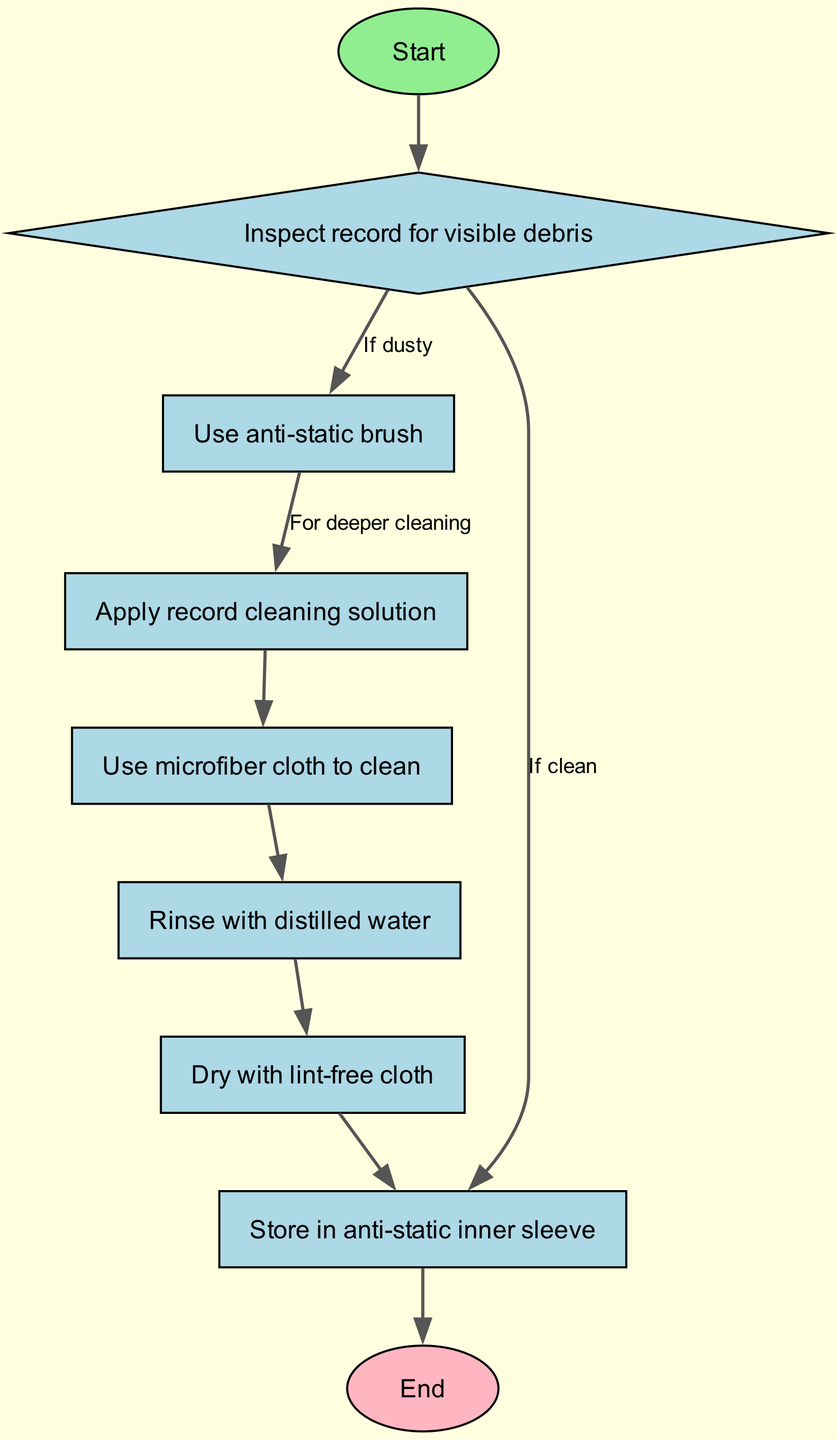What is the starting point of the process? The starting point is represented by the node labeled 'Start' at the top of the flow chart. It directs to the first main action of inspecting the record.
Answer: Start How many nodes are present in the diagram? The diagram contains a total of 7 nodes, which are the individual steps relevant to the vinyl record cleaning process.
Answer: 7 What is the action taken if the record is clean? If the record is clean, the process moves directly to the storage in an anti-static inner sleeve, bypassing the cleaning steps.
Answer: Store in anti-static inner sleeve What comes after applying the cleaning solution? After applying the record cleaning solution, the next step is to clean the record with a microfiber cloth. This follows logically as a part of the cleaning process.
Answer: Use microfiber cloth to clean What step follows rinsing with distilled water? The step that follows rinsing with distilled water is drying the record with a lint-free cloth, which helps ensure that no water residue is left.
Answer: Dry with lint-free cloth What action is taken when the record is dusty? When the record is dusty, the process continues to use an anti-static brush to remove dust before applying any cleaning solutions for optimal care.
Answer: Use anti-static brush What is the final step in the process? The final step in the process, following drying the record, is storing it in an anti-static inner sleeve, which preserves the record's condition.
Answer: Store in anti-static inner sleeve If the record is not dusty, what is the next action taken? If the record is not dusty, it skips directly to storing the record in an anti-static inner sleeve, ensuring it is safely preserved without unnecessary cleaning steps.
Answer: Store in anti-static inner sleeve What is the purpose of using a microfiber cloth? The purpose of using a microfiber cloth is to effectively clean the record's surface without causing scratches, making sure that the cleaning solution is thoroughly wiped off.
Answer: Use microfiber cloth to clean 